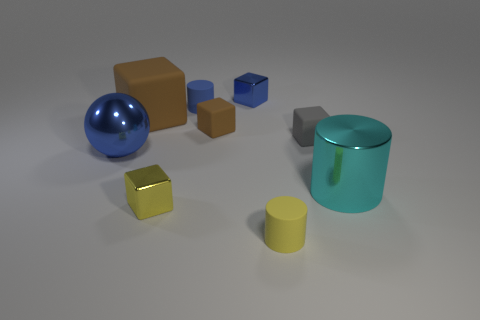Subtract all tiny matte cylinders. How many cylinders are left? 1 Subtract all gray cubes. How many cubes are left? 4 Add 1 green rubber cubes. How many objects exist? 10 Subtract all cylinders. How many objects are left? 6 Subtract 2 cylinders. How many cylinders are left? 1 Add 6 yellow shiny cubes. How many yellow shiny cubes exist? 7 Subtract 1 gray blocks. How many objects are left? 8 Subtract all green cylinders. Subtract all red balls. How many cylinders are left? 3 Subtract all blue balls. How many cyan cylinders are left? 1 Subtract all tiny matte blocks. Subtract all tiny gray blocks. How many objects are left? 6 